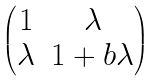Convert formula to latex. <formula><loc_0><loc_0><loc_500><loc_500>\begin{pmatrix} 1 & \lambda \\ \lambda & 1 + b \lambda \end{pmatrix}</formula> 